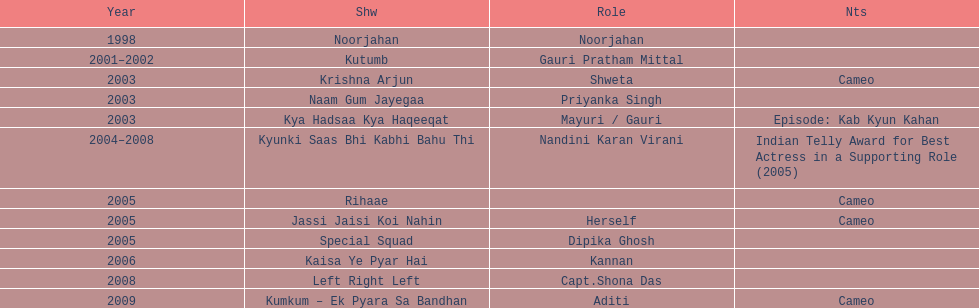What is the total number of tv series in which gauri tejwani has appeared, either as a star or in a cameo role? 11. 